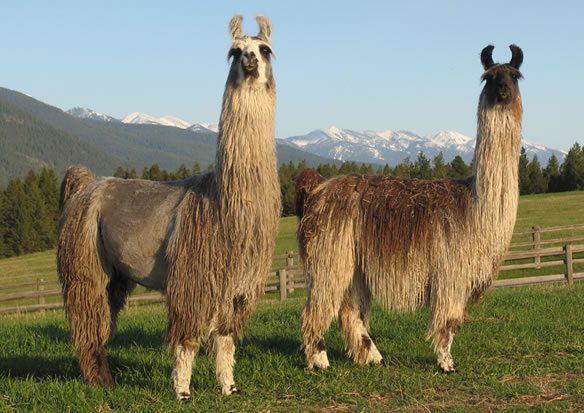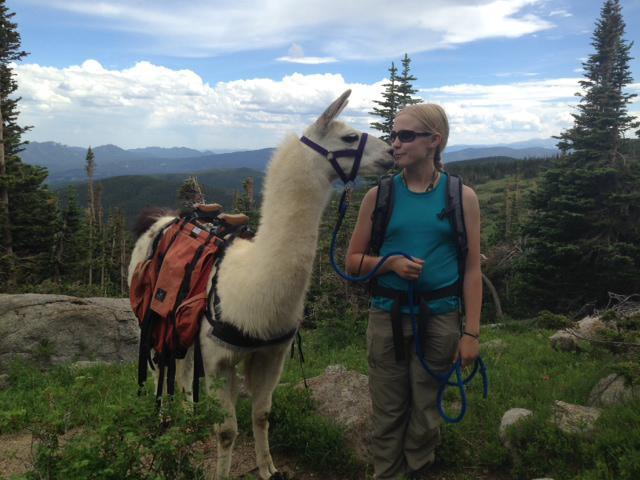The first image is the image on the left, the second image is the image on the right. Considering the images on both sides, is "A woman in a tank top is standing to the right of a llama and holding a blue rope attached to its harness." valid? Answer yes or no. Yes. The first image is the image on the left, the second image is the image on the right. For the images shown, is this caption "All the llamas have leashes." true? Answer yes or no. No. 